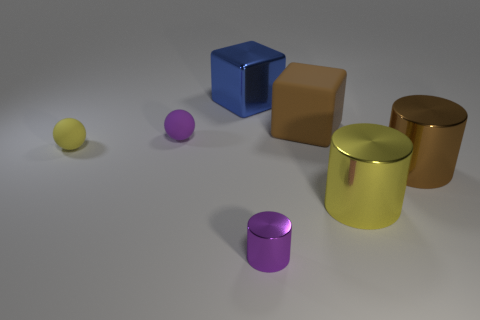How big is the metallic object that is on the left side of the purple object that is in front of the tiny matte object right of the small yellow rubber object?
Your answer should be very brief. Large. What number of other things are there of the same shape as the large yellow thing?
Your answer should be compact. 2. Do the brown thing behind the large brown metal object and the big brown thing that is right of the big yellow thing have the same shape?
Your answer should be very brief. No. How many cylinders are large brown metal objects or purple shiny things?
Keep it short and to the point. 2. What material is the brown object behind the brown thing that is in front of the large cube that is right of the large metallic cube?
Your response must be concise. Rubber. How many other objects are there of the same size as the purple rubber thing?
Provide a succinct answer. 2. What is the size of the matte ball that is the same color as the tiny cylinder?
Your answer should be very brief. Small. Is the number of blue cubes that are behind the blue block greater than the number of matte spheres?
Provide a succinct answer. No. Are there any metal blocks of the same color as the matte block?
Your response must be concise. No. The other rubber object that is the same size as the purple rubber thing is what color?
Your answer should be very brief. Yellow. 